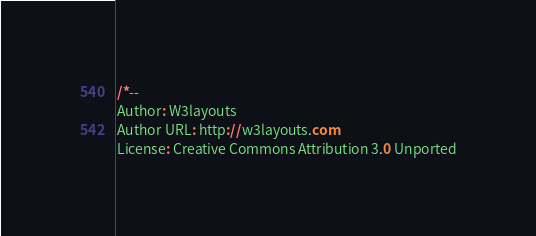Convert code to text. <code><loc_0><loc_0><loc_500><loc_500><_CSS_>/*--
Author: W3layouts
Author URL: http://w3layouts.com
License: Creative Commons Attribution 3.0 Unported</code> 